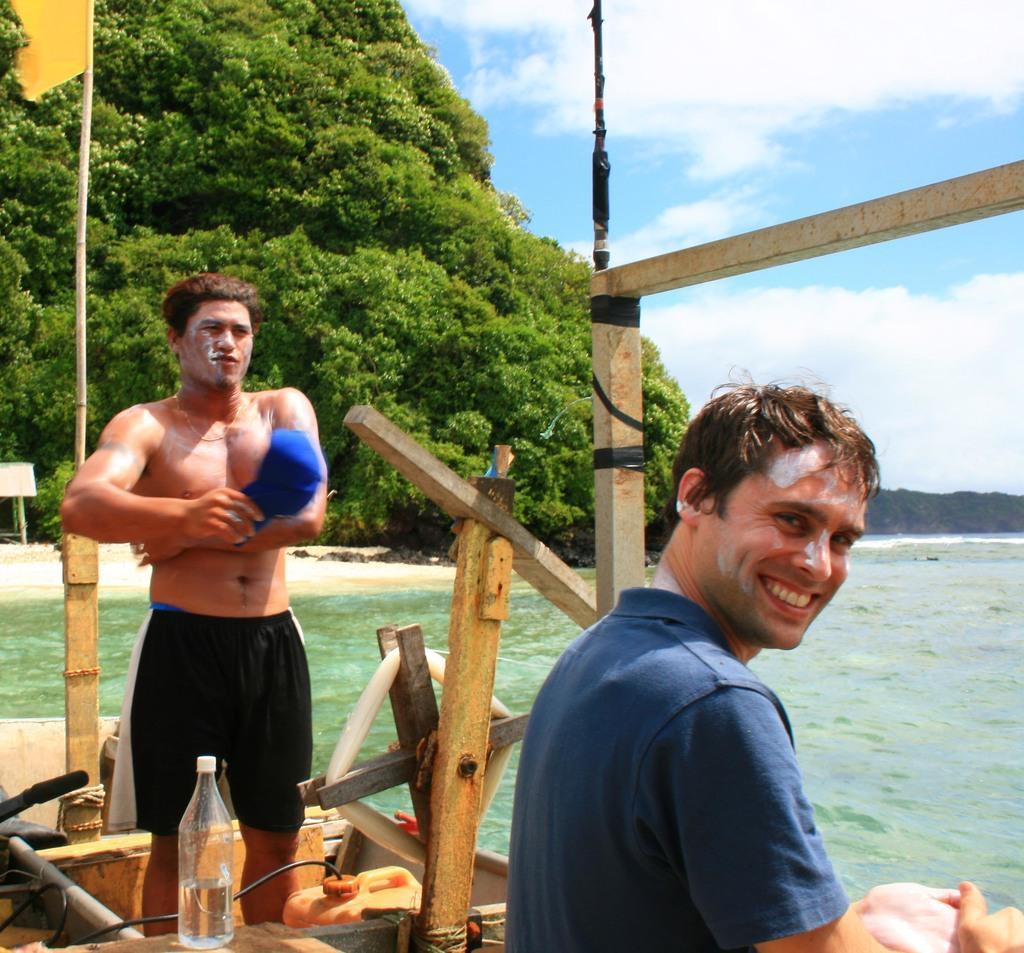Please provide a concise description of this image. This image is clicked near the beach. There are trees on the left side and sky on the right side. This image might be clicked in a boat. there is a flag on left side corner. There are two persons in this boat. one of them who is sitting in the right side is smiling and the other one who is standing is wearing black short, he is also holding something in blue color. There is a bottle in front of him and can too. The person on the right side is wearing blue shirt. There is also water in this image. 